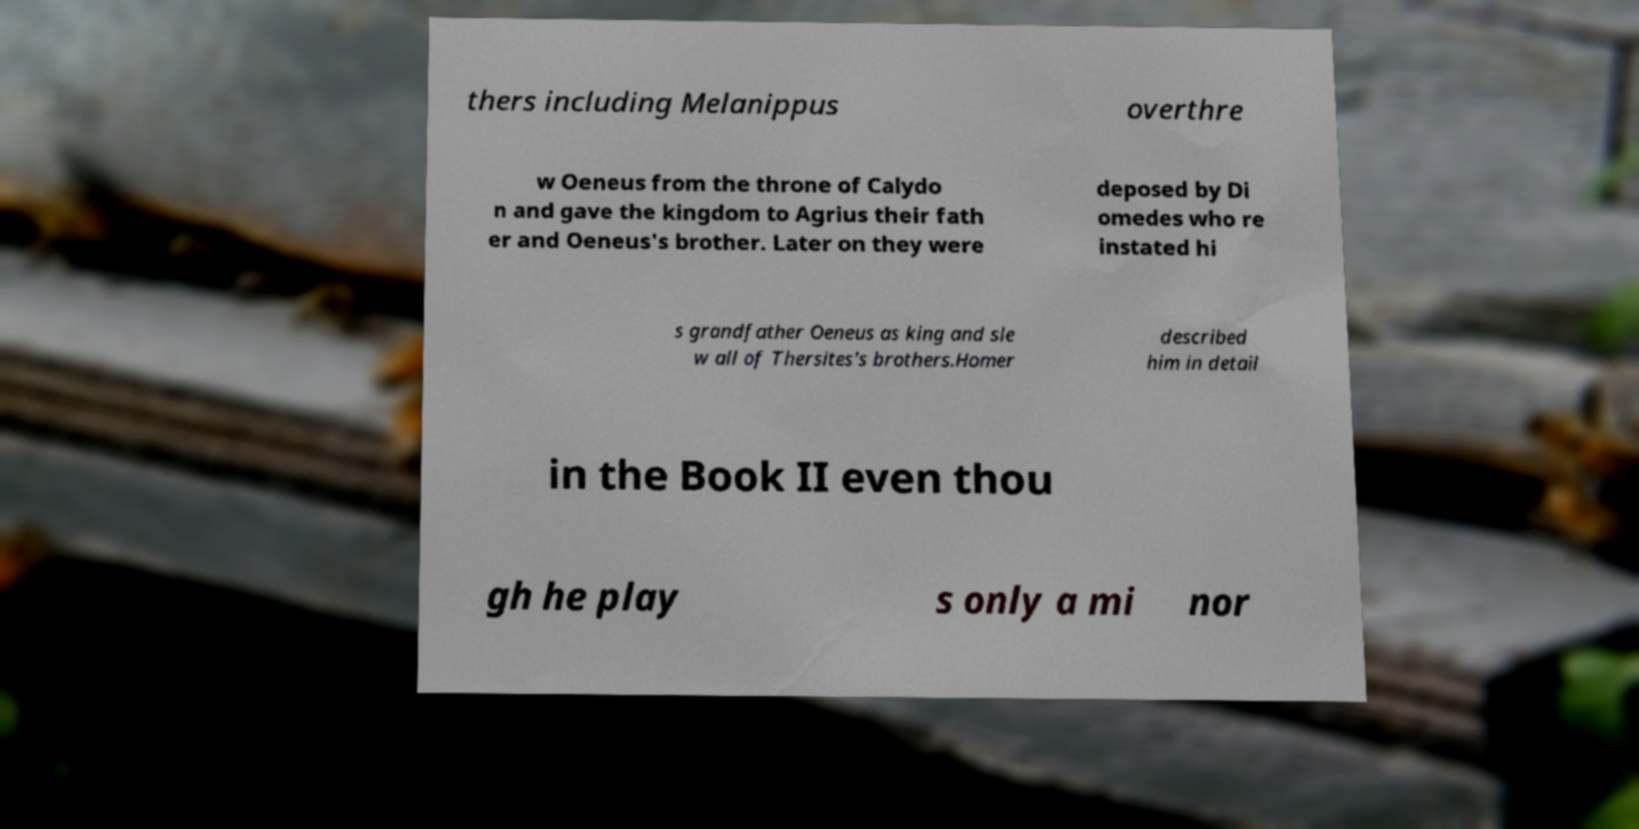Please read and relay the text visible in this image. What does it say? thers including Melanippus overthre w Oeneus from the throne of Calydo n and gave the kingdom to Agrius their fath er and Oeneus's brother. Later on they were deposed by Di omedes who re instated hi s grandfather Oeneus as king and sle w all of Thersites's brothers.Homer described him in detail in the Book II even thou gh he play s only a mi nor 